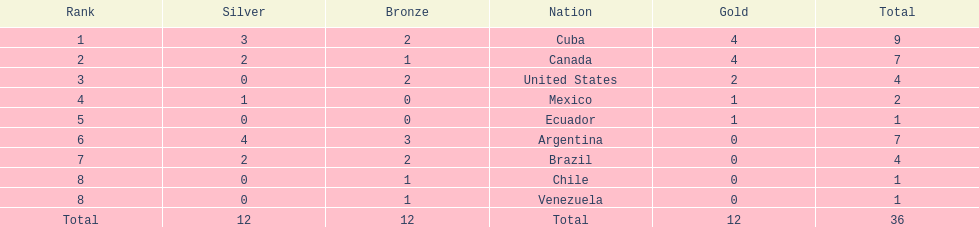How many total medals were there all together? 36. Could you parse the entire table? {'header': ['Rank', 'Silver', 'Bronze', 'Nation', 'Gold', 'Total'], 'rows': [['1', '3', '2', 'Cuba', '4', '9'], ['2', '2', '1', 'Canada', '4', '7'], ['3', '0', '2', 'United States', '2', '4'], ['4', '1', '0', 'Mexico', '1', '2'], ['5', '0', '0', 'Ecuador', '1', '1'], ['6', '4', '3', 'Argentina', '0', '7'], ['7', '2', '2', 'Brazil', '0', '4'], ['8', '0', '1', 'Chile', '0', '1'], ['8', '0', '1', 'Venezuela', '0', '1'], ['Total', '12', '12', 'Total', '12', '36']]} 